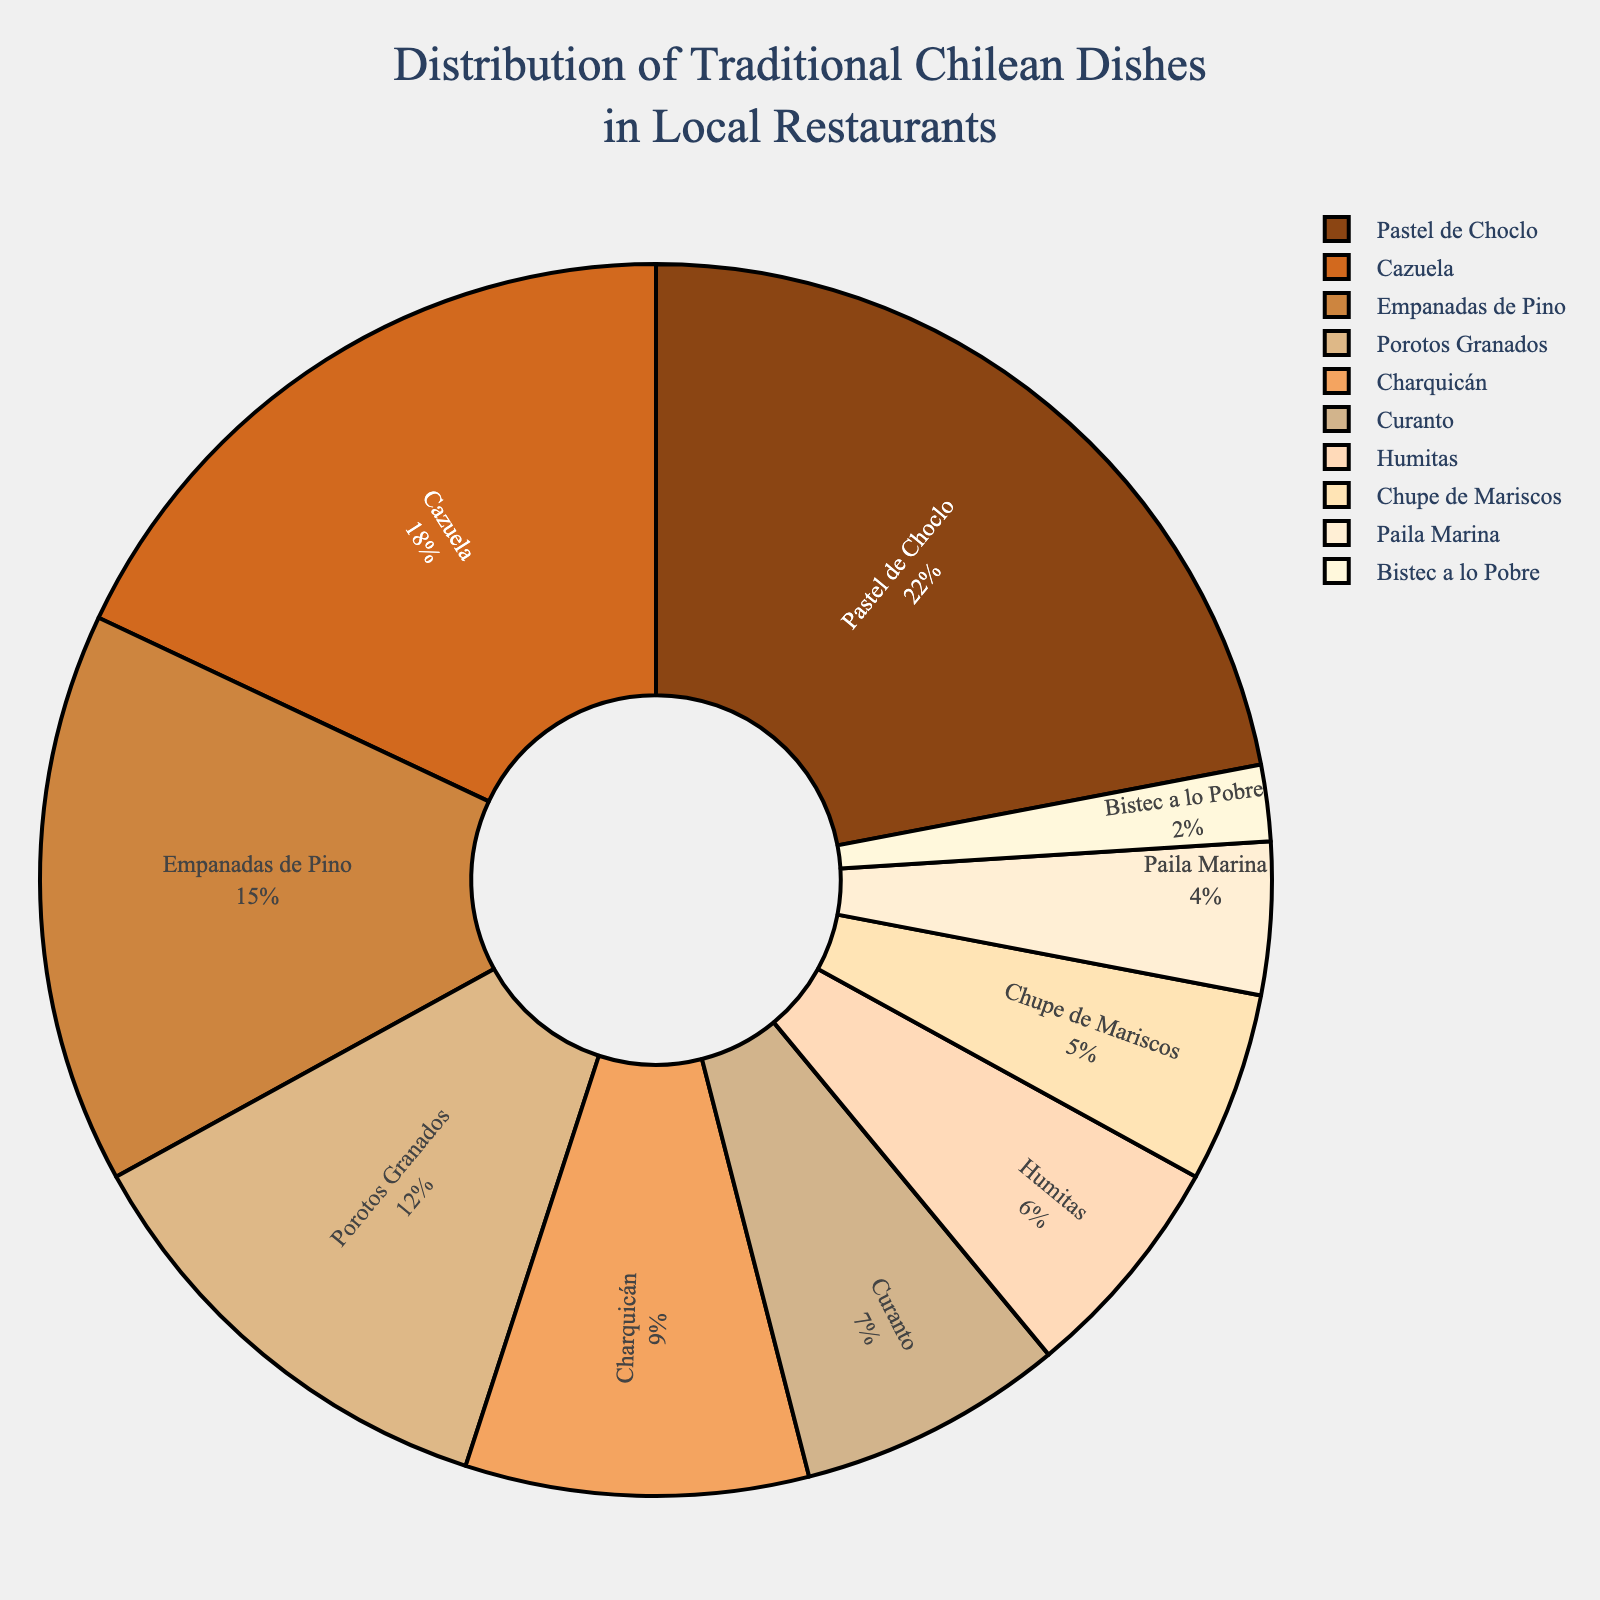What is the most popular traditional Chilean dish in local restaurants? The largest segment in the pie chart represents the dish with the highest percentage. From the chart, "Pastel de Choclo" has the largest segment.
Answer: Pastel de Choclo Which two dishes have the closest percentage values, and what are their percentages? Comparing the percentages visually, "Porotos Granados" and "Charquicán" appear to have closely matched sizes, 12% and 9% respectively.
Answer: Porotos Granados (12%) and Charquicán (9%) What is the combined percentage of "Curanto" and "Humitas"? To find the combined percentage, add the individual percentages of "Curanto" (7%) and "Humitas" (6%). 7% + 6% = 13%.
Answer: 13% Which dish has the smallest representation in local restaurants, and what is its percentage? The smallest segment in the pie chart represents the dish with the lowest percentage. "Bistec a lo Pobre" has the smallest segment with 2%.
Answer: Bistec a lo Pobre (2%) How much more popular is "Pastel de Choclo" compared to "Bistec a lo Pobre"? Subtract the percentage of "Bistec a lo Pobre" (2%) from "Pastel de Choclo" (22%). 22% - 2% = 20%.
Answer: 20% If you combine "Empanadas de Pino" and "Chupe de Mariscos", what fraction of the total do they represent? Sum the percentages of "Empanadas de Pino" (15%) and "Chupe de Mariscos" (5%) to get 20%. This means they represent 20% of the total.
Answer: 20% Between "Cazuela" and "Paila Marina", which dish is more popular and by how much? The percentage for "Cazuela" is 18%, whereas for "Paila Marina" it is 4%. Subtract the percentage of "Paila Marina" from "Cazuela" to find the difference, 18% - 4% = 14%.
Answer: Cazuela by 14% What is the median percentage value for all the dishes? First, list the percentages in order: 2, 4, 5, 6, 7, 9, 12, 15, 18, 22. The median is the middle value, so for 10 values, average the 5th and 6th values, (7% and 9%) / 2 = 8%.
Answer: 8% Which dish has a percentage value that is exactly half of "Pastel de Choclo"? "Pastel de Choclo" has 22%. Looking at the chart, "Porotos Granados" with 12% is close to half of 22%, but not exactly. There is no dish with exactly half, but "Porotos Granados" is closest.
Answer: None exactly; closest: Porotos Granados (12%) How does the percentage of "Charquicán" compare to the sum of "Curanto" and "Humitas"? "Charquicán" has 9%, while "Curanto" (7%) and "Humitas" (6%) together sum to 7% + 6% = 13%. 9% is less than 13%.
Answer: Less 